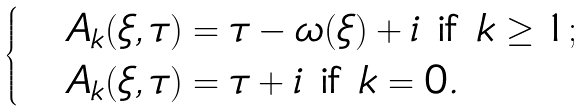Convert formula to latex. <formula><loc_0><loc_0><loc_500><loc_500>\begin{cases} & A _ { k } ( \xi , \tau ) = \tau - \omega ( \xi ) + i \text { if } k \geq 1 ; \\ & A _ { k } ( \xi , \tau ) = \tau + i \text { if } k = 0 . \\ \end{cases}</formula> 